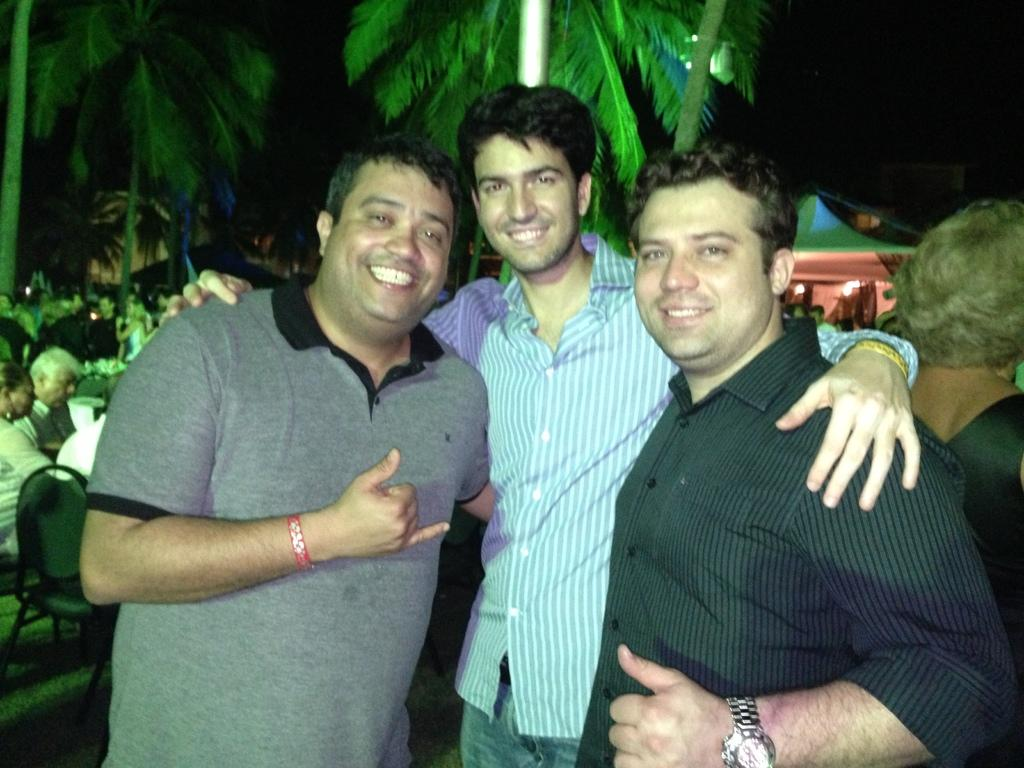How many people are in the image? There are people in the image, but the exact number is not specified. What are some of the people doing in the image? Some people are standing, and some are sitting on chairs. What can be seen in the background of the image? There are buildings and trees in the background of the image. Where is the kettle located in the image? There is no kettle present in the image. What direction are the people facing in the image? The facts provided do not specify the direction the people are facing. 